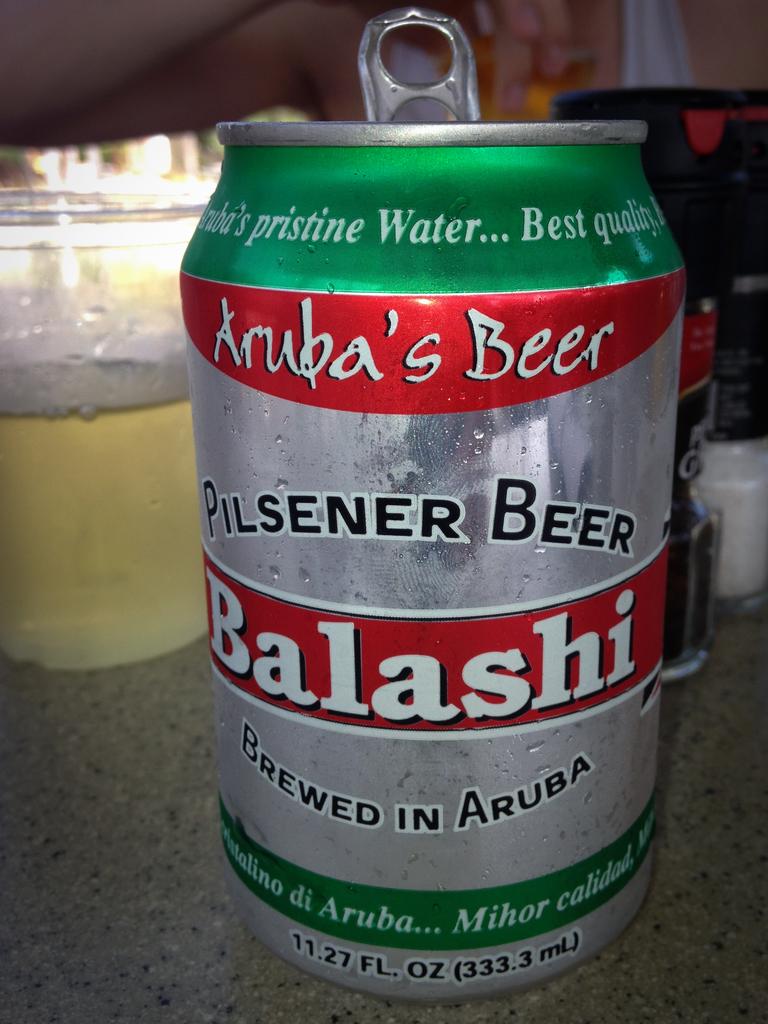Where was it brewed?
Your response must be concise. Aruba. 